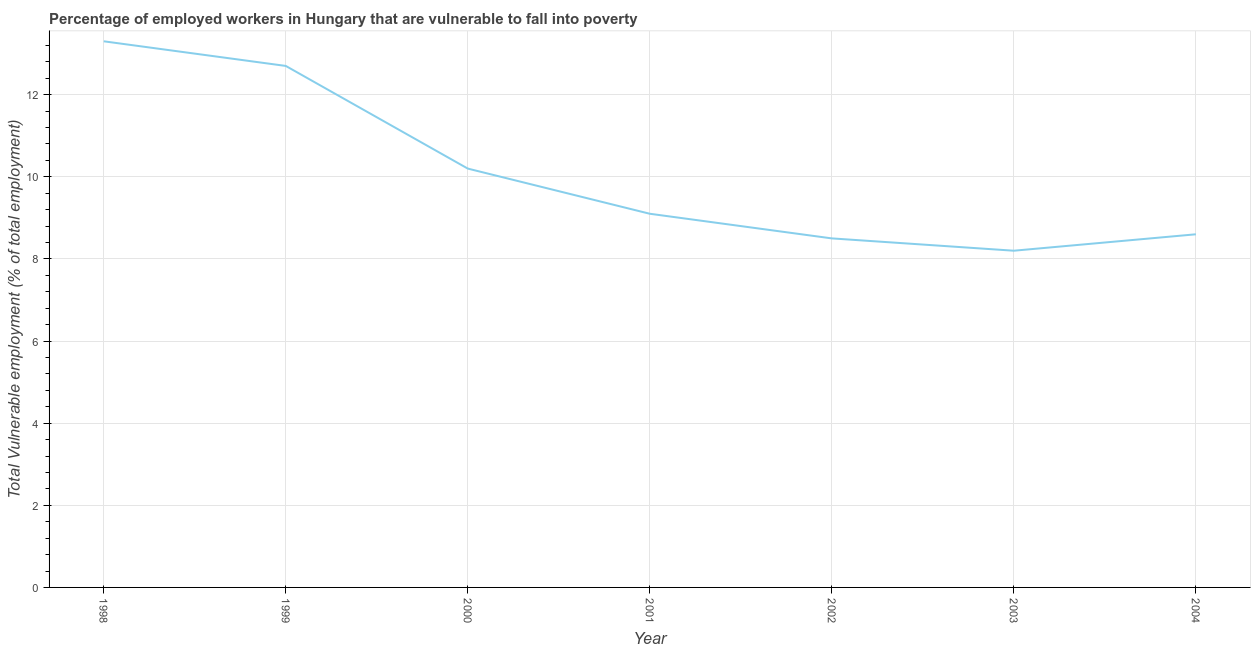What is the total vulnerable employment in 1999?
Keep it short and to the point. 12.7. Across all years, what is the maximum total vulnerable employment?
Your answer should be very brief. 13.3. Across all years, what is the minimum total vulnerable employment?
Give a very brief answer. 8.2. In which year was the total vulnerable employment maximum?
Your answer should be compact. 1998. What is the sum of the total vulnerable employment?
Provide a succinct answer. 70.6. What is the difference between the total vulnerable employment in 1998 and 1999?
Offer a very short reply. 0.6. What is the average total vulnerable employment per year?
Keep it short and to the point. 10.09. What is the median total vulnerable employment?
Offer a very short reply. 9.1. Do a majority of the years between 2003 and 2002 (inclusive) have total vulnerable employment greater than 5.6 %?
Your response must be concise. No. What is the ratio of the total vulnerable employment in 1998 to that in 2002?
Your answer should be very brief. 1.56. Is the total vulnerable employment in 2000 less than that in 2001?
Make the answer very short. No. What is the difference between the highest and the second highest total vulnerable employment?
Ensure brevity in your answer.  0.6. Is the sum of the total vulnerable employment in 2000 and 2004 greater than the maximum total vulnerable employment across all years?
Keep it short and to the point. Yes. What is the difference between the highest and the lowest total vulnerable employment?
Your answer should be very brief. 5.1. In how many years, is the total vulnerable employment greater than the average total vulnerable employment taken over all years?
Ensure brevity in your answer.  3. How many lines are there?
Keep it short and to the point. 1. What is the difference between two consecutive major ticks on the Y-axis?
Offer a very short reply. 2. Are the values on the major ticks of Y-axis written in scientific E-notation?
Offer a terse response. No. Does the graph contain any zero values?
Provide a short and direct response. No. What is the title of the graph?
Make the answer very short. Percentage of employed workers in Hungary that are vulnerable to fall into poverty. What is the label or title of the X-axis?
Give a very brief answer. Year. What is the label or title of the Y-axis?
Your answer should be very brief. Total Vulnerable employment (% of total employment). What is the Total Vulnerable employment (% of total employment) of 1998?
Offer a terse response. 13.3. What is the Total Vulnerable employment (% of total employment) in 1999?
Keep it short and to the point. 12.7. What is the Total Vulnerable employment (% of total employment) in 2000?
Provide a succinct answer. 10.2. What is the Total Vulnerable employment (% of total employment) in 2001?
Your response must be concise. 9.1. What is the Total Vulnerable employment (% of total employment) of 2003?
Your answer should be compact. 8.2. What is the Total Vulnerable employment (% of total employment) in 2004?
Offer a very short reply. 8.6. What is the difference between the Total Vulnerable employment (% of total employment) in 1998 and 1999?
Provide a short and direct response. 0.6. What is the difference between the Total Vulnerable employment (% of total employment) in 1998 and 2002?
Make the answer very short. 4.8. What is the difference between the Total Vulnerable employment (% of total employment) in 1999 and 2002?
Your response must be concise. 4.2. What is the difference between the Total Vulnerable employment (% of total employment) in 1999 and 2004?
Ensure brevity in your answer.  4.1. What is the difference between the Total Vulnerable employment (% of total employment) in 2001 and 2002?
Your response must be concise. 0.6. What is the difference between the Total Vulnerable employment (% of total employment) in 2001 and 2003?
Your response must be concise. 0.9. What is the difference between the Total Vulnerable employment (% of total employment) in 2001 and 2004?
Give a very brief answer. 0.5. What is the difference between the Total Vulnerable employment (% of total employment) in 2002 and 2004?
Give a very brief answer. -0.1. What is the difference between the Total Vulnerable employment (% of total employment) in 2003 and 2004?
Your answer should be very brief. -0.4. What is the ratio of the Total Vulnerable employment (% of total employment) in 1998 to that in 1999?
Offer a terse response. 1.05. What is the ratio of the Total Vulnerable employment (% of total employment) in 1998 to that in 2000?
Provide a succinct answer. 1.3. What is the ratio of the Total Vulnerable employment (% of total employment) in 1998 to that in 2001?
Provide a short and direct response. 1.46. What is the ratio of the Total Vulnerable employment (% of total employment) in 1998 to that in 2002?
Your answer should be very brief. 1.56. What is the ratio of the Total Vulnerable employment (% of total employment) in 1998 to that in 2003?
Your response must be concise. 1.62. What is the ratio of the Total Vulnerable employment (% of total employment) in 1998 to that in 2004?
Provide a succinct answer. 1.55. What is the ratio of the Total Vulnerable employment (% of total employment) in 1999 to that in 2000?
Give a very brief answer. 1.25. What is the ratio of the Total Vulnerable employment (% of total employment) in 1999 to that in 2001?
Provide a short and direct response. 1.4. What is the ratio of the Total Vulnerable employment (% of total employment) in 1999 to that in 2002?
Give a very brief answer. 1.49. What is the ratio of the Total Vulnerable employment (% of total employment) in 1999 to that in 2003?
Your answer should be compact. 1.55. What is the ratio of the Total Vulnerable employment (% of total employment) in 1999 to that in 2004?
Provide a short and direct response. 1.48. What is the ratio of the Total Vulnerable employment (% of total employment) in 2000 to that in 2001?
Your answer should be very brief. 1.12. What is the ratio of the Total Vulnerable employment (% of total employment) in 2000 to that in 2002?
Ensure brevity in your answer.  1.2. What is the ratio of the Total Vulnerable employment (% of total employment) in 2000 to that in 2003?
Your response must be concise. 1.24. What is the ratio of the Total Vulnerable employment (% of total employment) in 2000 to that in 2004?
Provide a short and direct response. 1.19. What is the ratio of the Total Vulnerable employment (% of total employment) in 2001 to that in 2002?
Provide a short and direct response. 1.07. What is the ratio of the Total Vulnerable employment (% of total employment) in 2001 to that in 2003?
Make the answer very short. 1.11. What is the ratio of the Total Vulnerable employment (% of total employment) in 2001 to that in 2004?
Your response must be concise. 1.06. What is the ratio of the Total Vulnerable employment (% of total employment) in 2002 to that in 2003?
Make the answer very short. 1.04. What is the ratio of the Total Vulnerable employment (% of total employment) in 2003 to that in 2004?
Provide a succinct answer. 0.95. 